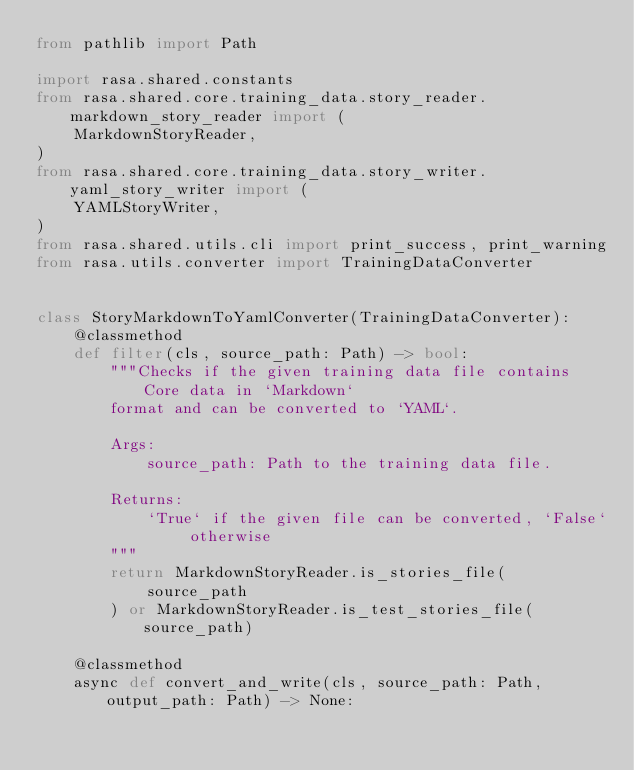<code> <loc_0><loc_0><loc_500><loc_500><_Python_>from pathlib import Path

import rasa.shared.constants
from rasa.shared.core.training_data.story_reader.markdown_story_reader import (
    MarkdownStoryReader,
)
from rasa.shared.core.training_data.story_writer.yaml_story_writer import (
    YAMLStoryWriter,
)
from rasa.shared.utils.cli import print_success, print_warning
from rasa.utils.converter import TrainingDataConverter


class StoryMarkdownToYamlConverter(TrainingDataConverter):
    @classmethod
    def filter(cls, source_path: Path) -> bool:
        """Checks if the given training data file contains Core data in `Markdown`
        format and can be converted to `YAML`.

        Args:
            source_path: Path to the training data file.

        Returns:
            `True` if the given file can be converted, `False` otherwise
        """
        return MarkdownStoryReader.is_stories_file(
            source_path
        ) or MarkdownStoryReader.is_test_stories_file(source_path)

    @classmethod
    async def convert_and_write(cls, source_path: Path, output_path: Path) -> None:</code> 